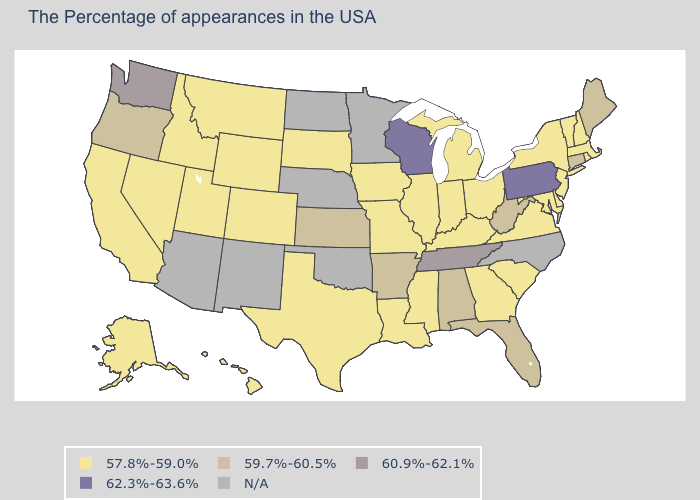What is the value of Arizona?
Write a very short answer. N/A. What is the highest value in the West ?
Concise answer only. 60.9%-62.1%. What is the value of Delaware?
Quick response, please. 57.8%-59.0%. Name the states that have a value in the range 57.8%-59.0%?
Short answer required. Massachusetts, Rhode Island, New Hampshire, Vermont, New York, New Jersey, Delaware, Maryland, Virginia, South Carolina, Ohio, Georgia, Michigan, Kentucky, Indiana, Illinois, Mississippi, Louisiana, Missouri, Iowa, Texas, South Dakota, Wyoming, Colorado, Utah, Montana, Idaho, Nevada, California, Alaska, Hawaii. Which states hav the highest value in the Northeast?
Write a very short answer. Pennsylvania. What is the value of Hawaii?
Keep it brief. 57.8%-59.0%. What is the lowest value in the Northeast?
Give a very brief answer. 57.8%-59.0%. Does Colorado have the lowest value in the USA?
Answer briefly. Yes. What is the highest value in the USA?
Quick response, please. 62.3%-63.6%. What is the value of Virginia?
Short answer required. 57.8%-59.0%. Which states hav the highest value in the Northeast?
Keep it brief. Pennsylvania. Does the first symbol in the legend represent the smallest category?
Be succinct. Yes. Name the states that have a value in the range N/A?
Keep it brief. North Carolina, Minnesota, Nebraska, Oklahoma, North Dakota, New Mexico, Arizona. 